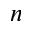Convert formula to latex. <formula><loc_0><loc_0><loc_500><loc_500>n</formula> 